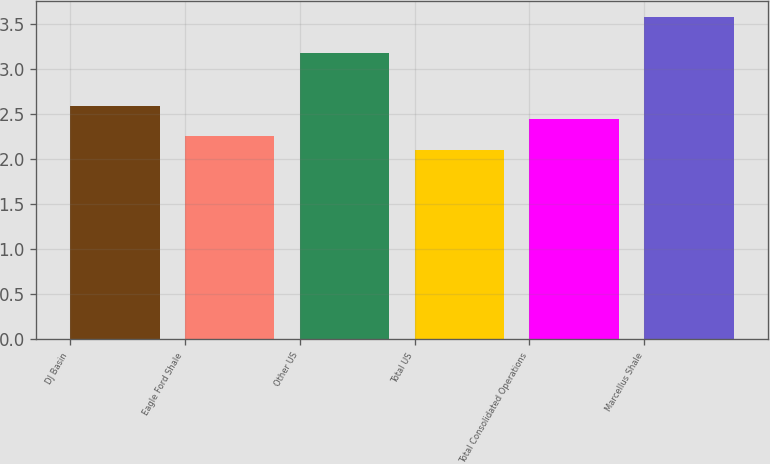Convert chart. <chart><loc_0><loc_0><loc_500><loc_500><bar_chart><fcel>DJ Basin<fcel>Eagle Ford Shale<fcel>Other US<fcel>Total US<fcel>Total Consolidated Operations<fcel>Marcellus Shale<nl><fcel>2.59<fcel>2.25<fcel>3.18<fcel>2.1<fcel>2.44<fcel>3.57<nl></chart> 